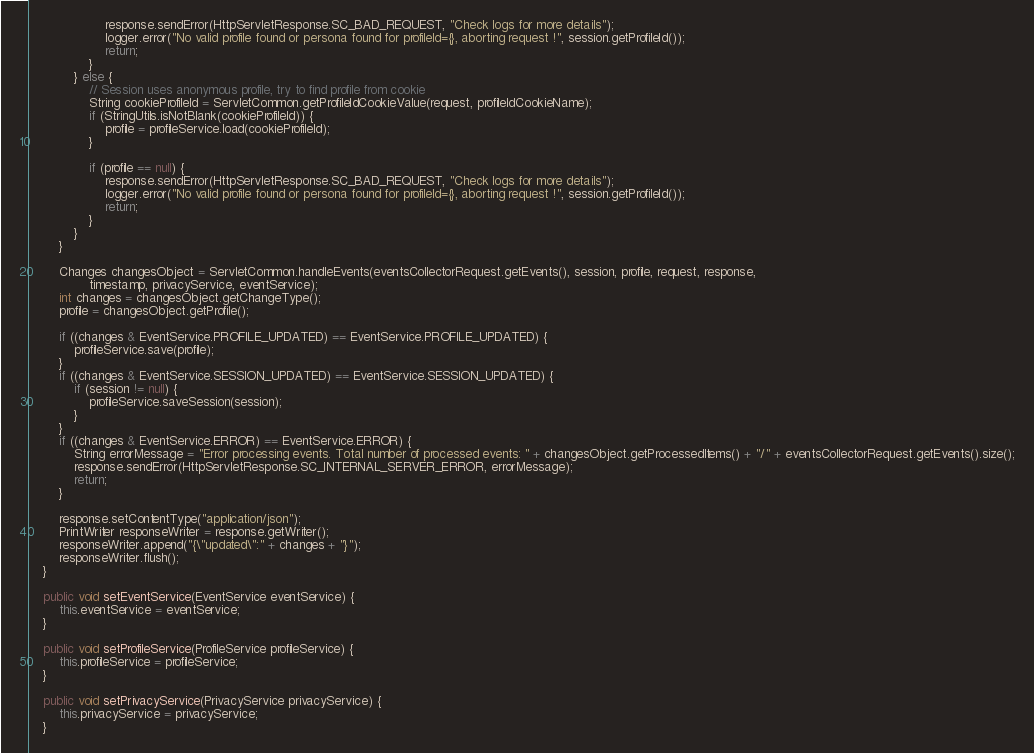Convert code to text. <code><loc_0><loc_0><loc_500><loc_500><_Java_>                    response.sendError(HttpServletResponse.SC_BAD_REQUEST, "Check logs for more details");
                    logger.error("No valid profile found or persona found for profileId={}, aborting request !", session.getProfileId());
                    return;
                }
            } else {
                // Session uses anonymous profile, try to find profile from cookie
                String cookieProfileId = ServletCommon.getProfileIdCookieValue(request, profileIdCookieName);
                if (StringUtils.isNotBlank(cookieProfileId)) {
                    profile = profileService.load(cookieProfileId);
                }

                if (profile == null) {
                    response.sendError(HttpServletResponse.SC_BAD_REQUEST, "Check logs for more details");
                    logger.error("No valid profile found or persona found for profileId={}, aborting request !", session.getProfileId());
                    return;
                }
            }
        }

        Changes changesObject = ServletCommon.handleEvents(eventsCollectorRequest.getEvents(), session, profile, request, response,
                timestamp, privacyService, eventService);
        int changes = changesObject.getChangeType();
        profile = changesObject.getProfile();

        if ((changes & EventService.PROFILE_UPDATED) == EventService.PROFILE_UPDATED) {
            profileService.save(profile);
        }
        if ((changes & EventService.SESSION_UPDATED) == EventService.SESSION_UPDATED) {
            if (session != null) {
                profileService.saveSession(session);
            }
        }
        if ((changes & EventService.ERROR) == EventService.ERROR) {
            String errorMessage = "Error processing events. Total number of processed events: " + changesObject.getProcessedItems() + "/" + eventsCollectorRequest.getEvents().size();
            response.sendError(HttpServletResponse.SC_INTERNAL_SERVER_ERROR, errorMessage);
            return;
        }

        response.setContentType("application/json");
        PrintWriter responseWriter = response.getWriter();
        responseWriter.append("{\"updated\":" + changes + "}");
        responseWriter.flush();
    }

    public void setEventService(EventService eventService) {
        this.eventService = eventService;
    }

    public void setProfileService(ProfileService profileService) {
        this.profileService = profileService;
    }

    public void setPrivacyService(PrivacyService privacyService) {
        this.privacyService = privacyService;
    }
</code> 